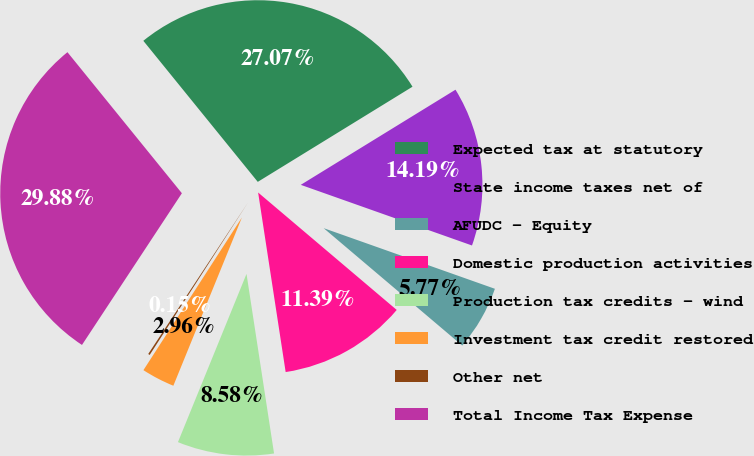Convert chart to OTSL. <chart><loc_0><loc_0><loc_500><loc_500><pie_chart><fcel>Expected tax at statutory<fcel>State income taxes net of<fcel>AFUDC - Equity<fcel>Domestic production activities<fcel>Production tax credits - wind<fcel>Investment tax credit restored<fcel>Other net<fcel>Total Income Tax Expense<nl><fcel>27.07%<fcel>14.19%<fcel>5.77%<fcel>11.39%<fcel>8.58%<fcel>2.96%<fcel>0.15%<fcel>29.88%<nl></chart> 